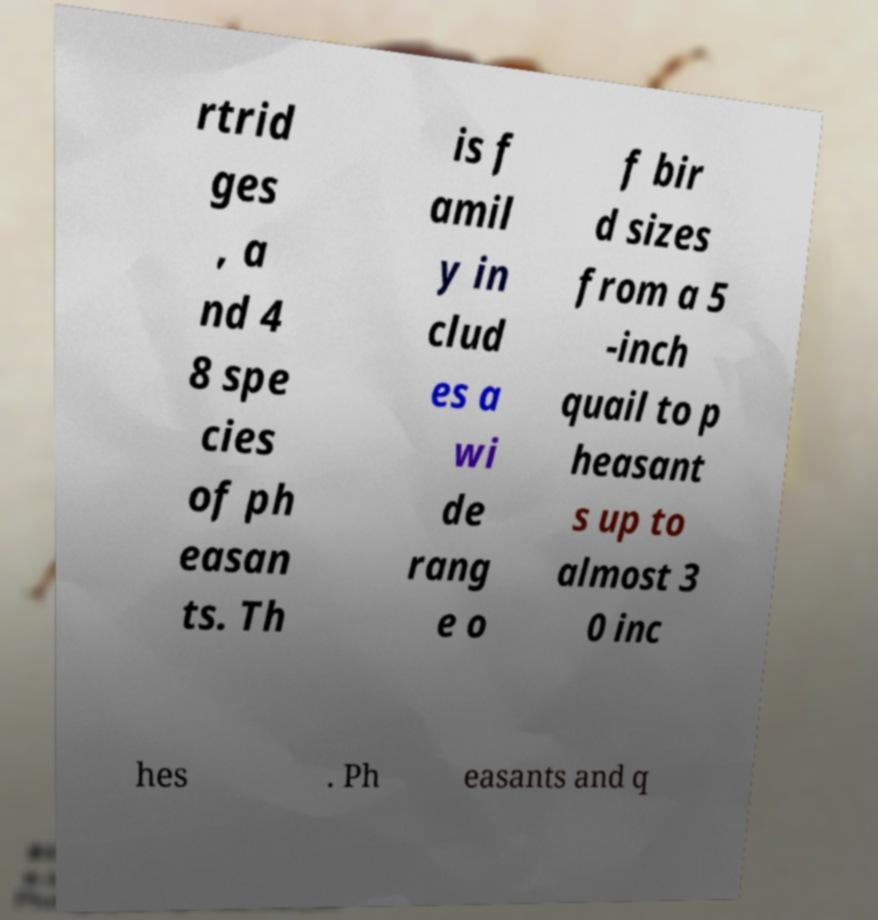Could you assist in decoding the text presented in this image and type it out clearly? rtrid ges , a nd 4 8 spe cies of ph easan ts. Th is f amil y in clud es a wi de rang e o f bir d sizes from a 5 -inch quail to p heasant s up to almost 3 0 inc hes . Ph easants and q 